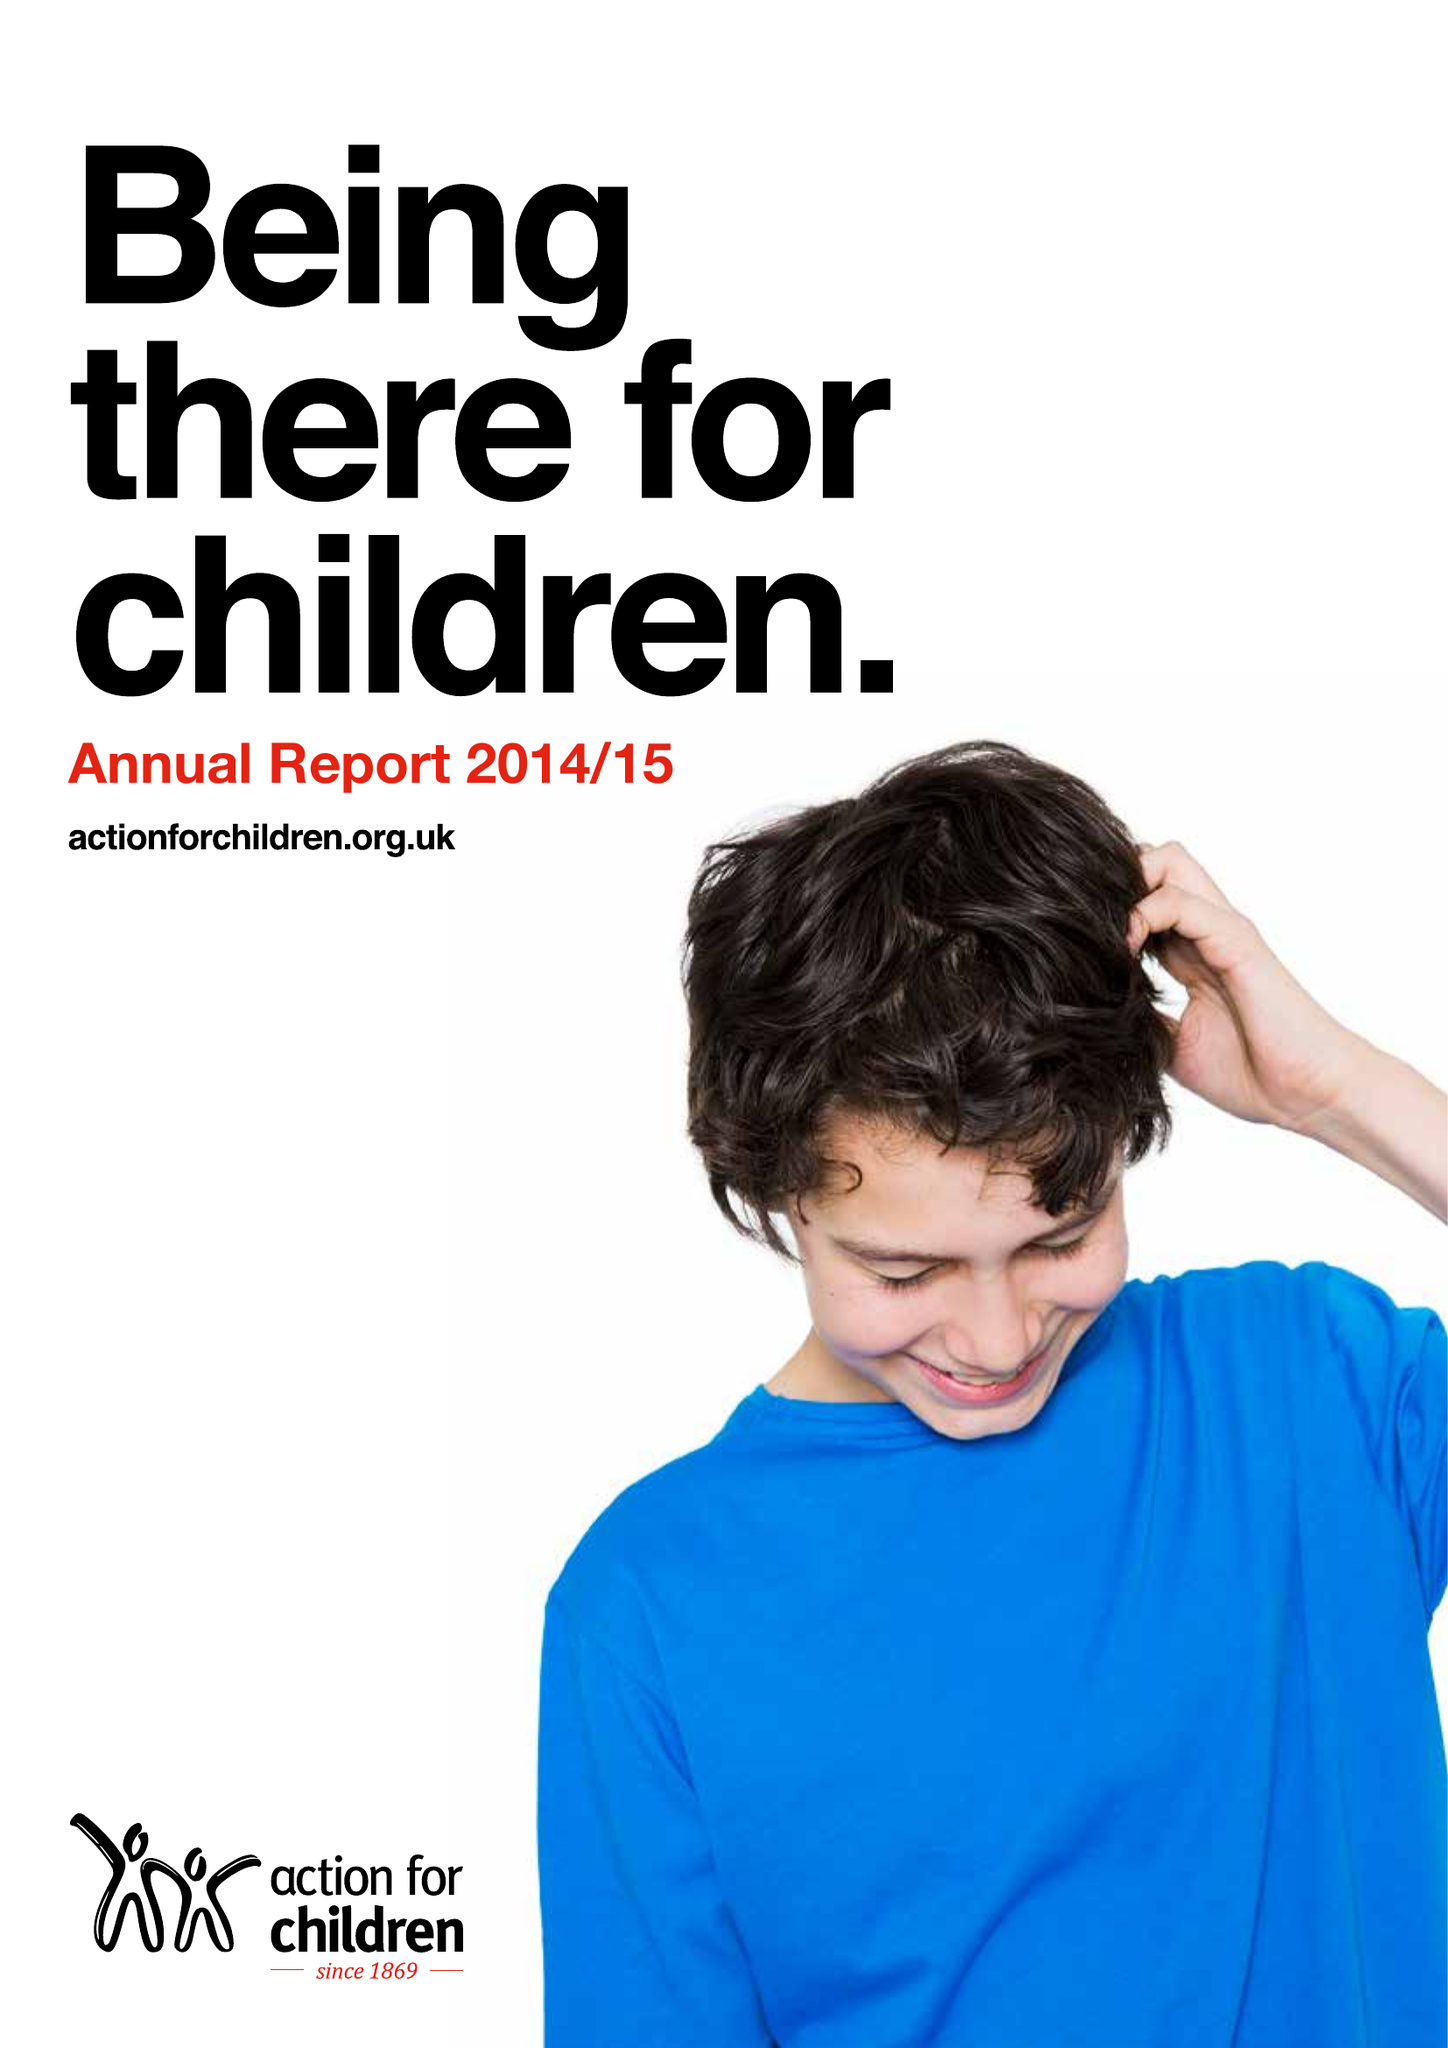What is the value for the charity_name?
Answer the question using a single word or phrase. Action For Children 